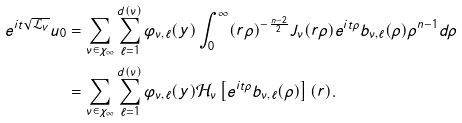Convert formula to latex. <formula><loc_0><loc_0><loc_500><loc_500>e ^ { i t \sqrt { \mathcal { L } _ { V } } } u _ { 0 } & = \sum _ { \nu \in \chi _ { \infty } } \sum _ { \ell = 1 } ^ { d ( \nu ) } \varphi _ { \nu , \ell } ( y ) \int _ { 0 } ^ { \infty } ( r \rho ) ^ { - \frac { n - 2 } 2 } J _ { \nu } ( r \rho ) e ^ { i t \rho } b _ { \nu , \ell } ( \rho ) \rho ^ { n - 1 } d \rho \\ & = \sum _ { \nu \in \chi _ { \infty } } \sum _ { \ell = 1 } ^ { d ( \nu ) } \varphi _ { \nu , \ell } ( y ) \mathcal { H } _ { \nu } \left [ e ^ { i t \rho } b _ { \nu , \ell } ( \rho ) \right ] ( r ) .</formula> 